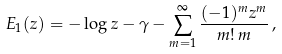Convert formula to latex. <formula><loc_0><loc_0><loc_500><loc_500>E _ { 1 } ( z ) = - \log z - \gamma - \sum _ { m = 1 } ^ { \infty } \frac { ( - 1 ) ^ { m } z ^ { m } } { m ! \, m } \, ,</formula> 